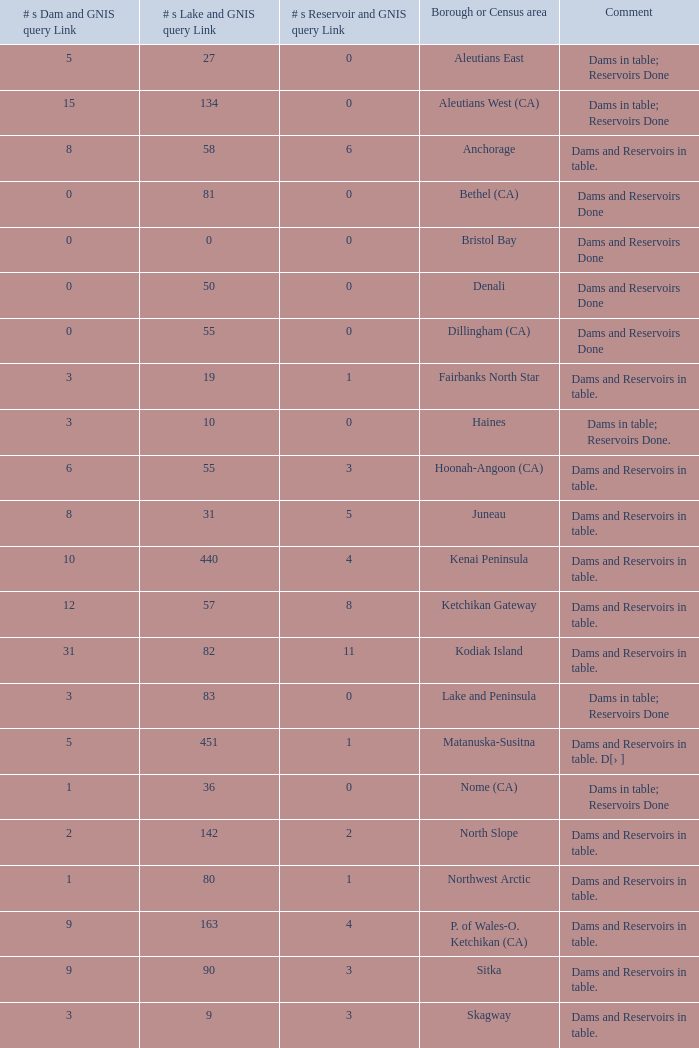What is the maximum number of dams and the corresponding gnis query link for a borough or census area within fairbanks north star? 3.0. Could you help me parse every detail presented in this table? {'header': ['# s Dam and GNIS query Link', '# s Lake and GNIS query Link', '# s Reservoir and GNIS query Link', 'Borough or Census area', 'Comment'], 'rows': [['5', '27', '0', 'Aleutians East', 'Dams in table; Reservoirs Done'], ['15', '134', '0', 'Aleutians West (CA)', 'Dams in table; Reservoirs Done'], ['8', '58', '6', 'Anchorage', 'Dams and Reservoirs in table.'], ['0', '81', '0', 'Bethel (CA)', 'Dams and Reservoirs Done'], ['0', '0', '0', 'Bristol Bay', 'Dams and Reservoirs Done'], ['0', '50', '0', 'Denali', 'Dams and Reservoirs Done'], ['0', '55', '0', 'Dillingham (CA)', 'Dams and Reservoirs Done'], ['3', '19', '1', 'Fairbanks North Star', 'Dams and Reservoirs in table.'], ['3', '10', '0', 'Haines', 'Dams in table; Reservoirs Done.'], ['6', '55', '3', 'Hoonah-Angoon (CA)', 'Dams and Reservoirs in table.'], ['8', '31', '5', 'Juneau', 'Dams and Reservoirs in table.'], ['10', '440', '4', 'Kenai Peninsula', 'Dams and Reservoirs in table.'], ['12', '57', '8', 'Ketchikan Gateway', 'Dams and Reservoirs in table.'], ['31', '82', '11', 'Kodiak Island', 'Dams and Reservoirs in table.'], ['3', '83', '0', 'Lake and Peninsula', 'Dams in table; Reservoirs Done'], ['5', '451', '1', 'Matanuska-Susitna', 'Dams and Reservoirs in table. D[› ]'], ['1', '36', '0', 'Nome (CA)', 'Dams in table; Reservoirs Done'], ['2', '142', '2', 'North Slope', 'Dams and Reservoirs in table.'], ['1', '80', '1', 'Northwest Arctic', 'Dams and Reservoirs in table.'], ['9', '163', '4', 'P. of Wales-O. Ketchikan (CA)', 'Dams and Reservoirs in table.'], ['9', '90', '3', 'Sitka', 'Dams and Reservoirs in table.'], ['3', '9', '3', 'Skagway', 'Dams and Reservoirs in table.'], ['0', '130', '0', 'Southeast Fairbanks (CA)', 'Dams and Reservoirs in table.'], ['22', '293', '10', 'Valdez-Cordova (CA)', 'Dams and Reservoirs in table.'], ['1', '21', '0', 'Wade Hampton (CA)', 'Dams in table; Reservoirs Done'], ['8', '60', '5', 'Wrangell-Petersburg (CA)', 'Dams and Reservoirs in table.'], ['0', '26', '0', 'Yakutat', 'Dams and Reservoirs Done'], ['2', '513', '0', 'Yukon-Koyukuk (CA)', 'Dams in table; Reservoirs Done']]} 